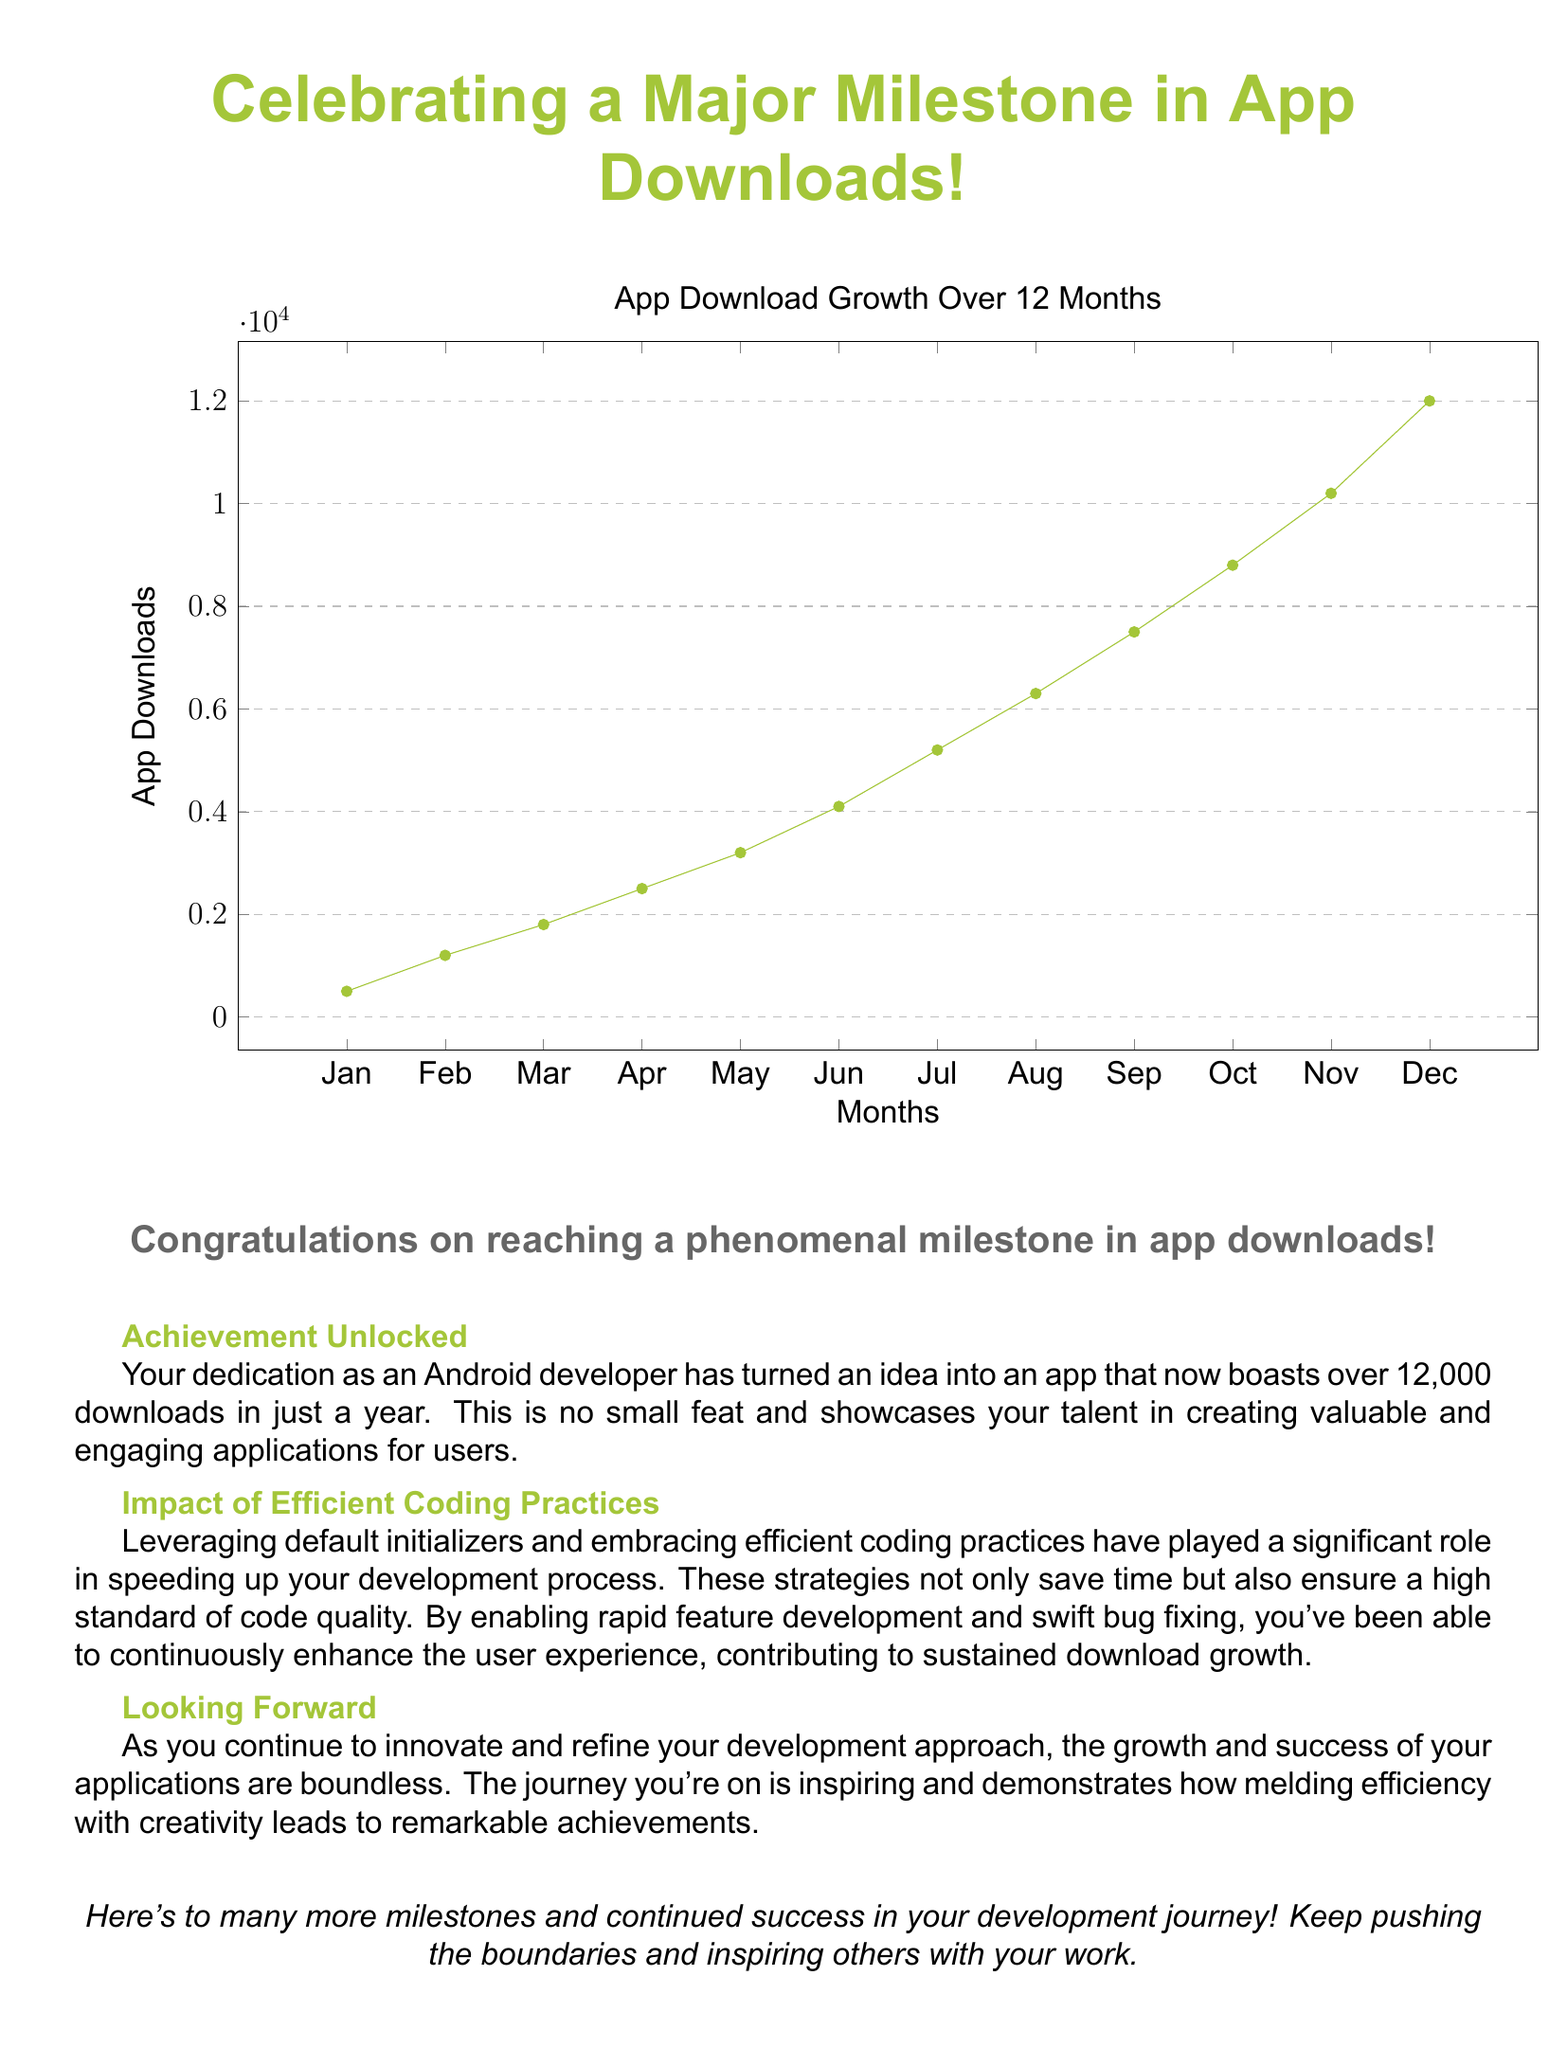What is the total number of app downloads? The total number of app downloads in the document is the final value in the graph, which is 12,000.
Answer: 12,000 What color represents the app download growth in the graph? The color used to represent app download growth in the graph is specified as 'androidgreen.'
Answer: androidgreen What is the achievement unlocked mentioned in the card? The achievement mentioned is the milestone of over 12,000 downloads in a year.
Answer: Over 12,000 downloads How many months of data are shown in the graph? The graph indicates app download data for 12 months based on the x-axis labeling.
Answer: 12 months What is the significance of efficient coding practices according to the card? Efficient coding practices have helped speed up the development process and maintain code quality.
Answer: Speed up development What does the title of the document emphasize? The title emphasizes the celebration of reaching a major milestone in app downloads.
Answer: Major milestone What message does the card wish for the future? The card wishes for many more milestones and continued success in the development journey.
Answer: Many more milestones What is the main font used in the document? The document specifies that the main font used is Arial.
Answer: Arial 